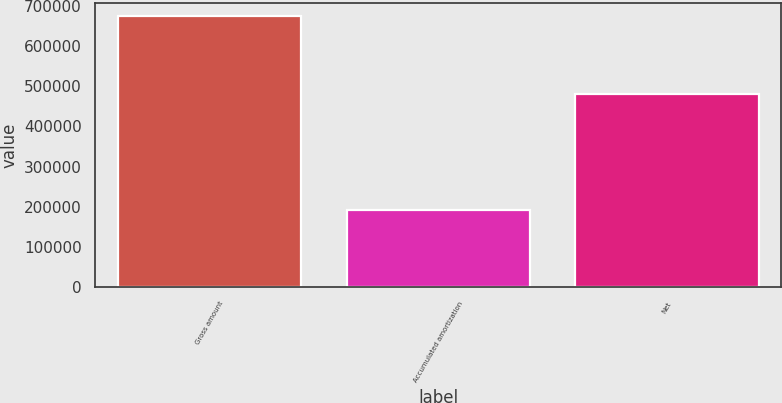Convert chart to OTSL. <chart><loc_0><loc_0><loc_500><loc_500><bar_chart><fcel>Gross amount<fcel>Accumulated amortization<fcel>Net<nl><fcel>673495<fcel>193442<fcel>480053<nl></chart> 